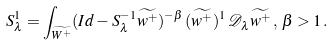Convert formula to latex. <formula><loc_0><loc_0><loc_500><loc_500>S ^ { 1 } _ { \lambda } = \int _ { \widetilde { W ^ { + } } } ( I d - S _ { \lambda } ^ { - 1 } \widetilde { w ^ { + } } ) ^ { - \beta } \, ( \widetilde { w ^ { + } } ) ^ { 1 } \, \mathcal { D } _ { \lambda } \widetilde { w ^ { + } } \, , \, \beta > 1 \, .</formula> 